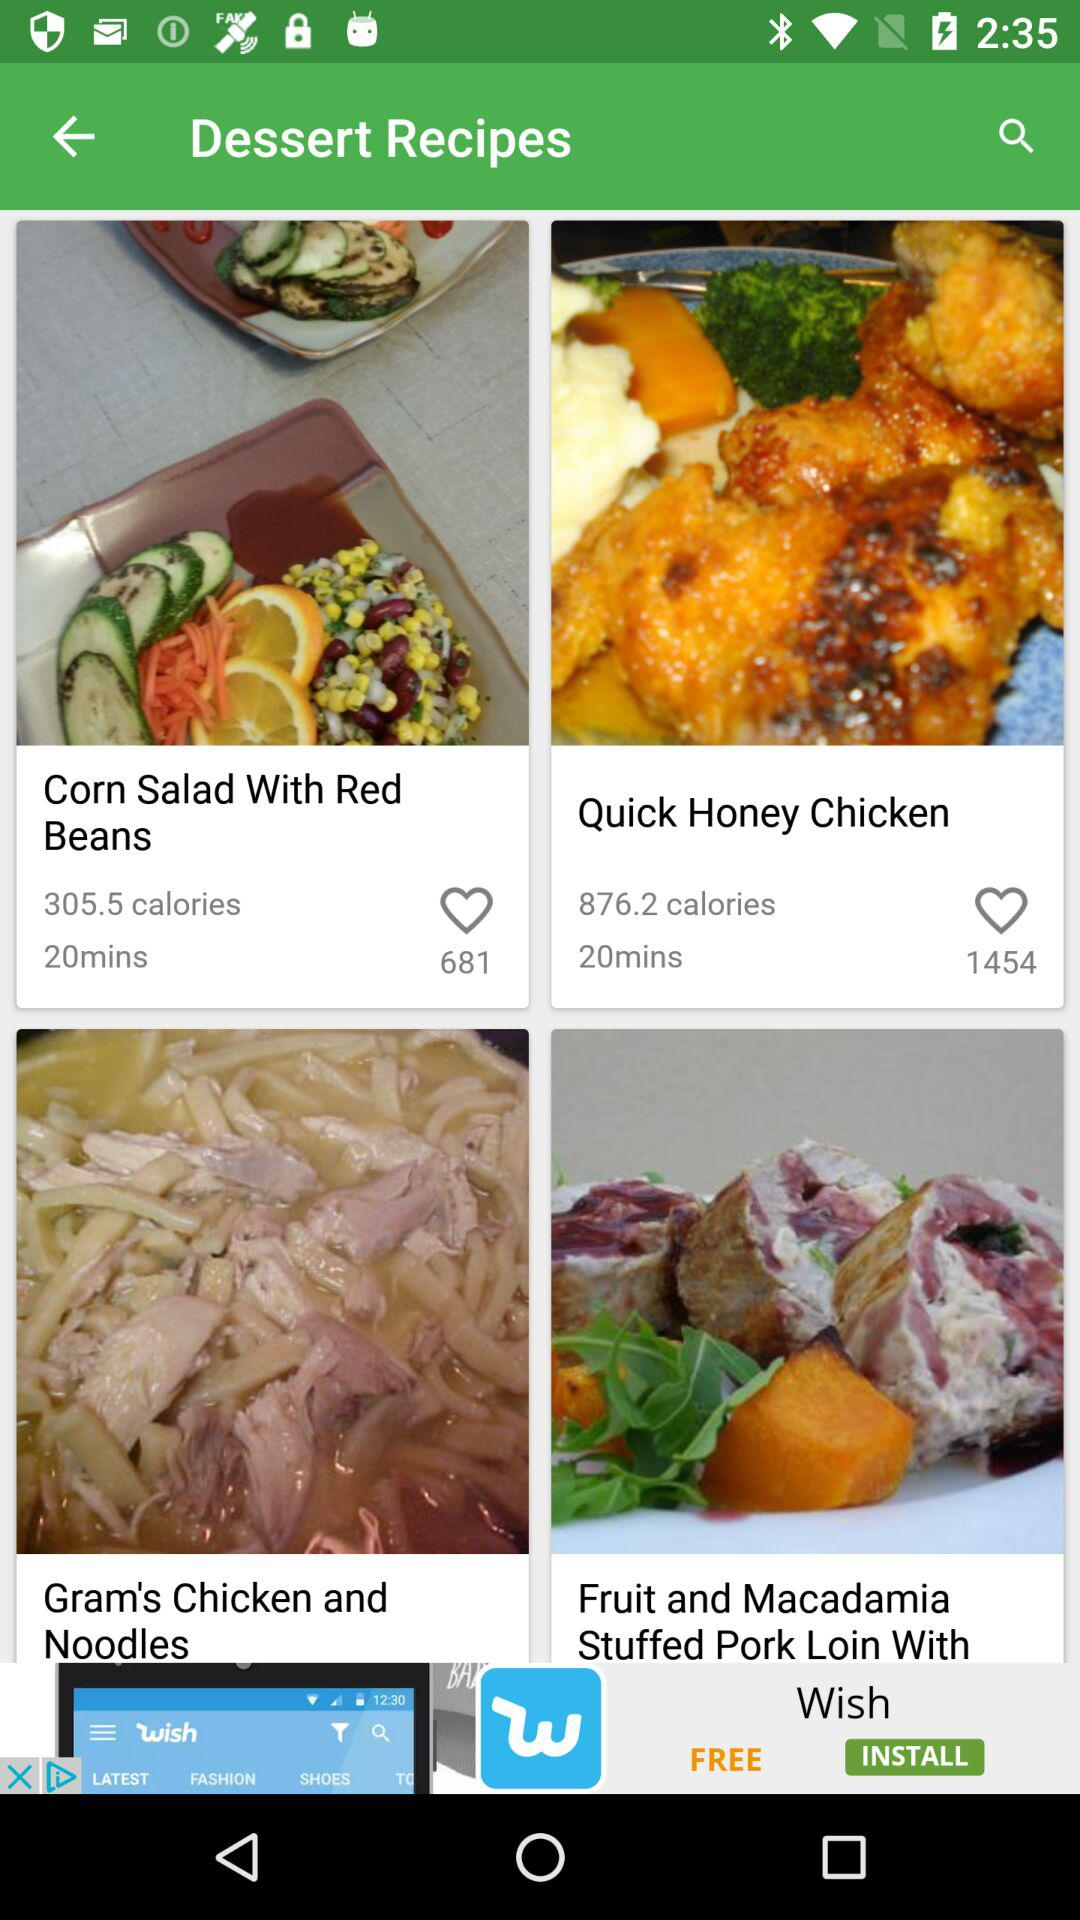How many people like the "Quick Honey Chicken" recipe? There are 1454 people who like the "Quick Honey Chicken" recipe. 